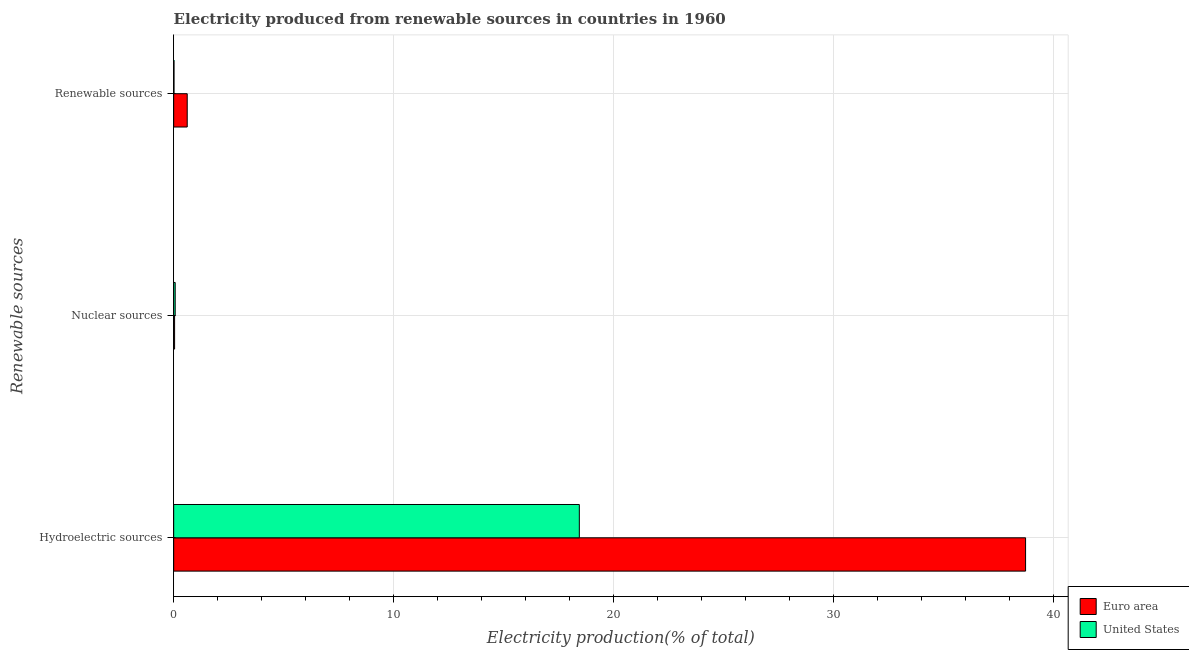Are the number of bars per tick equal to the number of legend labels?
Provide a short and direct response. Yes. How many bars are there on the 2nd tick from the top?
Offer a very short reply. 2. What is the label of the 3rd group of bars from the top?
Offer a terse response. Hydroelectric sources. What is the percentage of electricity produced by renewable sources in United States?
Give a very brief answer. 0.02. Across all countries, what is the maximum percentage of electricity produced by renewable sources?
Your answer should be compact. 0.62. Across all countries, what is the minimum percentage of electricity produced by hydroelectric sources?
Offer a terse response. 18.44. What is the total percentage of electricity produced by nuclear sources in the graph?
Ensure brevity in your answer.  0.11. What is the difference between the percentage of electricity produced by nuclear sources in United States and that in Euro area?
Provide a short and direct response. 0.03. What is the difference between the percentage of electricity produced by renewable sources in Euro area and the percentage of electricity produced by nuclear sources in United States?
Ensure brevity in your answer.  0.55. What is the average percentage of electricity produced by nuclear sources per country?
Your response must be concise. 0.06. What is the difference between the percentage of electricity produced by hydroelectric sources and percentage of electricity produced by renewable sources in United States?
Offer a very short reply. 18.42. What is the ratio of the percentage of electricity produced by renewable sources in Euro area to that in United States?
Your answer should be very brief. 40.34. Is the percentage of electricity produced by nuclear sources in United States less than that in Euro area?
Offer a terse response. No. What is the difference between the highest and the second highest percentage of electricity produced by hydroelectric sources?
Make the answer very short. 20.29. What is the difference between the highest and the lowest percentage of electricity produced by hydroelectric sources?
Offer a very short reply. 20.29. In how many countries, is the percentage of electricity produced by nuclear sources greater than the average percentage of electricity produced by nuclear sources taken over all countries?
Give a very brief answer. 1. Is the sum of the percentage of electricity produced by nuclear sources in United States and Euro area greater than the maximum percentage of electricity produced by hydroelectric sources across all countries?
Ensure brevity in your answer.  No. What does the 2nd bar from the bottom in Hydroelectric sources represents?
Provide a succinct answer. United States. Is it the case that in every country, the sum of the percentage of electricity produced by hydroelectric sources and percentage of electricity produced by nuclear sources is greater than the percentage of electricity produced by renewable sources?
Ensure brevity in your answer.  Yes. How many bars are there?
Ensure brevity in your answer.  6. How many countries are there in the graph?
Provide a short and direct response. 2. Are the values on the major ticks of X-axis written in scientific E-notation?
Your answer should be very brief. No. Does the graph contain any zero values?
Provide a short and direct response. No. How many legend labels are there?
Ensure brevity in your answer.  2. What is the title of the graph?
Your answer should be very brief. Electricity produced from renewable sources in countries in 1960. Does "Singapore" appear as one of the legend labels in the graph?
Your response must be concise. No. What is the label or title of the X-axis?
Offer a very short reply. Electricity production(% of total). What is the label or title of the Y-axis?
Your response must be concise. Renewable sources. What is the Electricity production(% of total) in Euro area in Hydroelectric sources?
Your answer should be compact. 38.73. What is the Electricity production(% of total) of United States in Hydroelectric sources?
Ensure brevity in your answer.  18.44. What is the Electricity production(% of total) of Euro area in Nuclear sources?
Your response must be concise. 0.04. What is the Electricity production(% of total) of United States in Nuclear sources?
Offer a very short reply. 0.07. What is the Electricity production(% of total) of Euro area in Renewable sources?
Offer a terse response. 0.62. What is the Electricity production(% of total) in United States in Renewable sources?
Make the answer very short. 0.02. Across all Renewable sources, what is the maximum Electricity production(% of total) of Euro area?
Provide a succinct answer. 38.73. Across all Renewable sources, what is the maximum Electricity production(% of total) of United States?
Provide a short and direct response. 18.44. Across all Renewable sources, what is the minimum Electricity production(% of total) in Euro area?
Ensure brevity in your answer.  0.04. Across all Renewable sources, what is the minimum Electricity production(% of total) in United States?
Offer a terse response. 0.02. What is the total Electricity production(% of total) in Euro area in the graph?
Your answer should be very brief. 39.38. What is the total Electricity production(% of total) in United States in the graph?
Provide a short and direct response. 18.52. What is the difference between the Electricity production(% of total) in Euro area in Hydroelectric sources and that in Nuclear sources?
Offer a terse response. 38.68. What is the difference between the Electricity production(% of total) in United States in Hydroelectric sources and that in Nuclear sources?
Provide a short and direct response. 18.37. What is the difference between the Electricity production(% of total) in Euro area in Hydroelectric sources and that in Renewable sources?
Your answer should be compact. 38.11. What is the difference between the Electricity production(% of total) in United States in Hydroelectric sources and that in Renewable sources?
Make the answer very short. 18.42. What is the difference between the Electricity production(% of total) in Euro area in Nuclear sources and that in Renewable sources?
Offer a very short reply. -0.57. What is the difference between the Electricity production(% of total) of United States in Nuclear sources and that in Renewable sources?
Offer a very short reply. 0.05. What is the difference between the Electricity production(% of total) in Euro area in Hydroelectric sources and the Electricity production(% of total) in United States in Nuclear sources?
Your answer should be compact. 38.66. What is the difference between the Electricity production(% of total) in Euro area in Hydroelectric sources and the Electricity production(% of total) in United States in Renewable sources?
Ensure brevity in your answer.  38.71. What is the difference between the Electricity production(% of total) in Euro area in Nuclear sources and the Electricity production(% of total) in United States in Renewable sources?
Keep it short and to the point. 0.03. What is the average Electricity production(% of total) in Euro area per Renewable sources?
Give a very brief answer. 13.13. What is the average Electricity production(% of total) of United States per Renewable sources?
Your answer should be very brief. 6.17. What is the difference between the Electricity production(% of total) in Euro area and Electricity production(% of total) in United States in Hydroelectric sources?
Provide a short and direct response. 20.29. What is the difference between the Electricity production(% of total) of Euro area and Electricity production(% of total) of United States in Nuclear sources?
Your answer should be compact. -0.03. What is the difference between the Electricity production(% of total) of Euro area and Electricity production(% of total) of United States in Renewable sources?
Provide a succinct answer. 0.6. What is the ratio of the Electricity production(% of total) of Euro area in Hydroelectric sources to that in Nuclear sources?
Provide a short and direct response. 929.7. What is the ratio of the Electricity production(% of total) of United States in Hydroelectric sources to that in Nuclear sources?
Your answer should be very brief. 266.17. What is the ratio of the Electricity production(% of total) in Euro area in Hydroelectric sources to that in Renewable sources?
Make the answer very short. 62.93. What is the ratio of the Electricity production(% of total) of United States in Hydroelectric sources to that in Renewable sources?
Provide a succinct answer. 1208.69. What is the ratio of the Electricity production(% of total) in Euro area in Nuclear sources to that in Renewable sources?
Your answer should be very brief. 0.07. What is the ratio of the Electricity production(% of total) of United States in Nuclear sources to that in Renewable sources?
Give a very brief answer. 4.54. What is the difference between the highest and the second highest Electricity production(% of total) of Euro area?
Ensure brevity in your answer.  38.11. What is the difference between the highest and the second highest Electricity production(% of total) of United States?
Your response must be concise. 18.37. What is the difference between the highest and the lowest Electricity production(% of total) of Euro area?
Offer a very short reply. 38.68. What is the difference between the highest and the lowest Electricity production(% of total) in United States?
Provide a succinct answer. 18.42. 